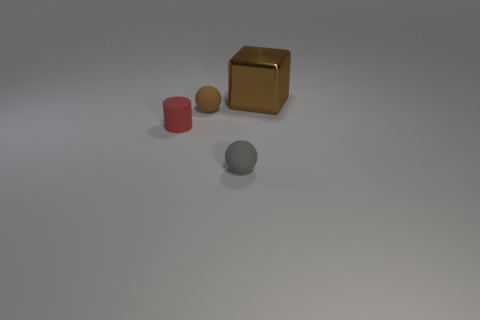Subtract all yellow blocks. Subtract all gray spheres. How many blocks are left? 1 Subtract all blue cylinders. How many purple spheres are left? 0 Add 2 things. How many big grays exist? 0 Subtract all red things. Subtract all gray rubber objects. How many objects are left? 2 Add 2 metal objects. How many metal objects are left? 3 Add 2 large yellow metal cylinders. How many large yellow metal cylinders exist? 2 Add 1 big green matte spheres. How many objects exist? 5 Subtract all gray spheres. How many spheres are left? 1 Subtract 0 green balls. How many objects are left? 4 Subtract all cylinders. How many objects are left? 3 